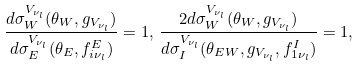Convert formula to latex. <formula><loc_0><loc_0><loc_500><loc_500>\frac { d \sigma _ { W } ^ { V _ { \nu _ { l } } } ( \theta _ { W } , g _ { V _ { \nu _ { l } } } ) } { d \sigma _ { E } ^ { V _ { \nu _ { l } } } ( \theta _ { E } , f _ { i \nu _ { l } } ^ { E } ) } = 1 , \, \frac { 2 d \sigma _ { W } ^ { V _ { \nu _ { l } } } ( \theta _ { W } , g _ { V _ { \nu _ { l } } } ) } { d \sigma _ { I } ^ { V _ { \nu _ { l } } } ( \theta _ { E W } , g _ { V _ { \nu _ { l } } } , f _ { 1 \nu _ { l } } ^ { I } ) } = 1 ,</formula> 